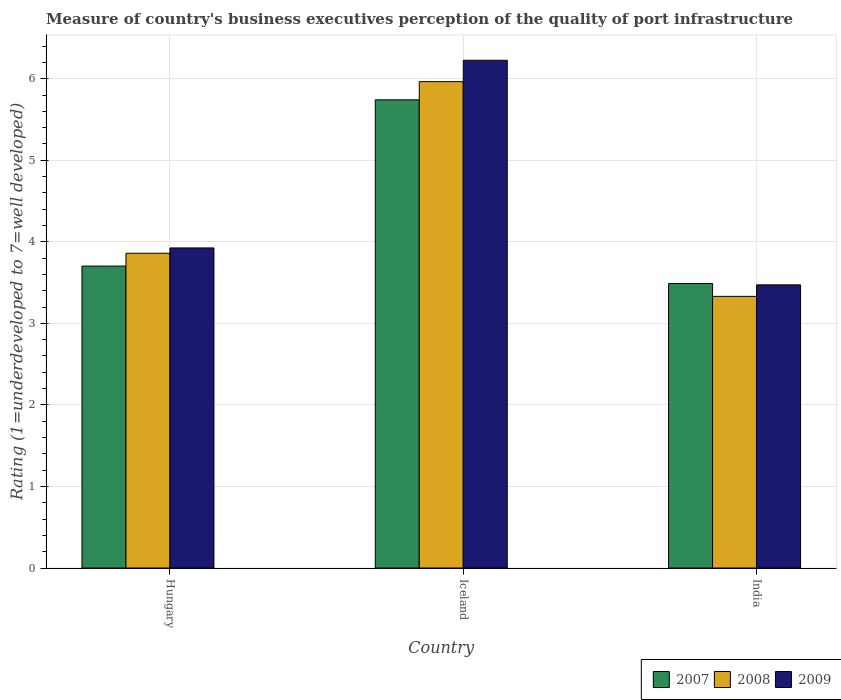Are the number of bars per tick equal to the number of legend labels?
Your answer should be very brief. Yes. How many bars are there on the 2nd tick from the left?
Provide a short and direct response. 3. In how many cases, is the number of bars for a given country not equal to the number of legend labels?
Your answer should be compact. 0. What is the ratings of the quality of port infrastructure in 2009 in Iceland?
Give a very brief answer. 6.23. Across all countries, what is the maximum ratings of the quality of port infrastructure in 2008?
Ensure brevity in your answer.  5.96. Across all countries, what is the minimum ratings of the quality of port infrastructure in 2007?
Ensure brevity in your answer.  3.49. In which country was the ratings of the quality of port infrastructure in 2009 maximum?
Your answer should be compact. Iceland. What is the total ratings of the quality of port infrastructure in 2009 in the graph?
Your answer should be compact. 13.62. What is the difference between the ratings of the quality of port infrastructure in 2008 in Hungary and that in Iceland?
Offer a terse response. -2.1. What is the difference between the ratings of the quality of port infrastructure in 2007 in Iceland and the ratings of the quality of port infrastructure in 2008 in India?
Ensure brevity in your answer.  2.41. What is the average ratings of the quality of port infrastructure in 2008 per country?
Your answer should be very brief. 4.39. What is the difference between the ratings of the quality of port infrastructure of/in 2008 and ratings of the quality of port infrastructure of/in 2007 in India?
Keep it short and to the point. -0.16. In how many countries, is the ratings of the quality of port infrastructure in 2008 greater than 1?
Your answer should be very brief. 3. What is the ratio of the ratings of the quality of port infrastructure in 2008 in Iceland to that in India?
Your answer should be very brief. 1.79. Is the difference between the ratings of the quality of port infrastructure in 2008 in Iceland and India greater than the difference between the ratings of the quality of port infrastructure in 2007 in Iceland and India?
Offer a very short reply. Yes. What is the difference between the highest and the second highest ratings of the quality of port infrastructure in 2008?
Ensure brevity in your answer.  -0.53. What is the difference between the highest and the lowest ratings of the quality of port infrastructure in 2007?
Your answer should be compact. 2.25. Is the sum of the ratings of the quality of port infrastructure in 2007 in Iceland and India greater than the maximum ratings of the quality of port infrastructure in 2009 across all countries?
Offer a very short reply. Yes. What does the 2nd bar from the right in India represents?
Keep it short and to the point. 2008. Is it the case that in every country, the sum of the ratings of the quality of port infrastructure in 2008 and ratings of the quality of port infrastructure in 2007 is greater than the ratings of the quality of port infrastructure in 2009?
Ensure brevity in your answer.  Yes. How many countries are there in the graph?
Give a very brief answer. 3. What is the difference between two consecutive major ticks on the Y-axis?
Ensure brevity in your answer.  1. Are the values on the major ticks of Y-axis written in scientific E-notation?
Provide a succinct answer. No. Does the graph contain grids?
Give a very brief answer. Yes. Where does the legend appear in the graph?
Ensure brevity in your answer.  Bottom right. What is the title of the graph?
Your response must be concise. Measure of country's business executives perception of the quality of port infrastructure. What is the label or title of the Y-axis?
Your answer should be very brief. Rating (1=underdeveloped to 7=well developed). What is the Rating (1=underdeveloped to 7=well developed) in 2007 in Hungary?
Give a very brief answer. 3.7. What is the Rating (1=underdeveloped to 7=well developed) of 2008 in Hungary?
Your answer should be very brief. 3.86. What is the Rating (1=underdeveloped to 7=well developed) of 2009 in Hungary?
Offer a very short reply. 3.93. What is the Rating (1=underdeveloped to 7=well developed) in 2007 in Iceland?
Offer a terse response. 5.74. What is the Rating (1=underdeveloped to 7=well developed) in 2008 in Iceland?
Provide a succinct answer. 5.96. What is the Rating (1=underdeveloped to 7=well developed) in 2009 in Iceland?
Your answer should be very brief. 6.23. What is the Rating (1=underdeveloped to 7=well developed) in 2007 in India?
Your answer should be very brief. 3.49. What is the Rating (1=underdeveloped to 7=well developed) of 2008 in India?
Your response must be concise. 3.33. What is the Rating (1=underdeveloped to 7=well developed) of 2009 in India?
Your response must be concise. 3.47. Across all countries, what is the maximum Rating (1=underdeveloped to 7=well developed) of 2007?
Keep it short and to the point. 5.74. Across all countries, what is the maximum Rating (1=underdeveloped to 7=well developed) of 2008?
Give a very brief answer. 5.96. Across all countries, what is the maximum Rating (1=underdeveloped to 7=well developed) in 2009?
Make the answer very short. 6.23. Across all countries, what is the minimum Rating (1=underdeveloped to 7=well developed) in 2007?
Make the answer very short. 3.49. Across all countries, what is the minimum Rating (1=underdeveloped to 7=well developed) of 2008?
Provide a short and direct response. 3.33. Across all countries, what is the minimum Rating (1=underdeveloped to 7=well developed) in 2009?
Ensure brevity in your answer.  3.47. What is the total Rating (1=underdeveloped to 7=well developed) of 2007 in the graph?
Your answer should be very brief. 12.93. What is the total Rating (1=underdeveloped to 7=well developed) of 2008 in the graph?
Your answer should be compact. 13.16. What is the total Rating (1=underdeveloped to 7=well developed) of 2009 in the graph?
Offer a very short reply. 13.62. What is the difference between the Rating (1=underdeveloped to 7=well developed) in 2007 in Hungary and that in Iceland?
Your answer should be very brief. -2.04. What is the difference between the Rating (1=underdeveloped to 7=well developed) in 2008 in Hungary and that in Iceland?
Give a very brief answer. -2.1. What is the difference between the Rating (1=underdeveloped to 7=well developed) of 2009 in Hungary and that in Iceland?
Your answer should be compact. -2.3. What is the difference between the Rating (1=underdeveloped to 7=well developed) of 2007 in Hungary and that in India?
Offer a very short reply. 0.21. What is the difference between the Rating (1=underdeveloped to 7=well developed) of 2008 in Hungary and that in India?
Give a very brief answer. 0.53. What is the difference between the Rating (1=underdeveloped to 7=well developed) of 2009 in Hungary and that in India?
Keep it short and to the point. 0.45. What is the difference between the Rating (1=underdeveloped to 7=well developed) in 2007 in Iceland and that in India?
Your answer should be compact. 2.25. What is the difference between the Rating (1=underdeveloped to 7=well developed) of 2008 in Iceland and that in India?
Ensure brevity in your answer.  2.63. What is the difference between the Rating (1=underdeveloped to 7=well developed) in 2009 in Iceland and that in India?
Your response must be concise. 2.75. What is the difference between the Rating (1=underdeveloped to 7=well developed) in 2007 in Hungary and the Rating (1=underdeveloped to 7=well developed) in 2008 in Iceland?
Provide a succinct answer. -2.26. What is the difference between the Rating (1=underdeveloped to 7=well developed) in 2007 in Hungary and the Rating (1=underdeveloped to 7=well developed) in 2009 in Iceland?
Your answer should be compact. -2.52. What is the difference between the Rating (1=underdeveloped to 7=well developed) of 2008 in Hungary and the Rating (1=underdeveloped to 7=well developed) of 2009 in Iceland?
Ensure brevity in your answer.  -2.37. What is the difference between the Rating (1=underdeveloped to 7=well developed) of 2007 in Hungary and the Rating (1=underdeveloped to 7=well developed) of 2008 in India?
Provide a short and direct response. 0.37. What is the difference between the Rating (1=underdeveloped to 7=well developed) of 2007 in Hungary and the Rating (1=underdeveloped to 7=well developed) of 2009 in India?
Offer a very short reply. 0.23. What is the difference between the Rating (1=underdeveloped to 7=well developed) in 2008 in Hungary and the Rating (1=underdeveloped to 7=well developed) in 2009 in India?
Make the answer very short. 0.39. What is the difference between the Rating (1=underdeveloped to 7=well developed) in 2007 in Iceland and the Rating (1=underdeveloped to 7=well developed) in 2008 in India?
Ensure brevity in your answer.  2.41. What is the difference between the Rating (1=underdeveloped to 7=well developed) in 2007 in Iceland and the Rating (1=underdeveloped to 7=well developed) in 2009 in India?
Ensure brevity in your answer.  2.27. What is the difference between the Rating (1=underdeveloped to 7=well developed) in 2008 in Iceland and the Rating (1=underdeveloped to 7=well developed) in 2009 in India?
Your answer should be very brief. 2.49. What is the average Rating (1=underdeveloped to 7=well developed) of 2007 per country?
Offer a very short reply. 4.31. What is the average Rating (1=underdeveloped to 7=well developed) in 2008 per country?
Give a very brief answer. 4.39. What is the average Rating (1=underdeveloped to 7=well developed) in 2009 per country?
Offer a terse response. 4.54. What is the difference between the Rating (1=underdeveloped to 7=well developed) in 2007 and Rating (1=underdeveloped to 7=well developed) in 2008 in Hungary?
Ensure brevity in your answer.  -0.16. What is the difference between the Rating (1=underdeveloped to 7=well developed) in 2007 and Rating (1=underdeveloped to 7=well developed) in 2009 in Hungary?
Offer a terse response. -0.22. What is the difference between the Rating (1=underdeveloped to 7=well developed) of 2008 and Rating (1=underdeveloped to 7=well developed) of 2009 in Hungary?
Offer a terse response. -0.06. What is the difference between the Rating (1=underdeveloped to 7=well developed) in 2007 and Rating (1=underdeveloped to 7=well developed) in 2008 in Iceland?
Ensure brevity in your answer.  -0.22. What is the difference between the Rating (1=underdeveloped to 7=well developed) in 2007 and Rating (1=underdeveloped to 7=well developed) in 2009 in Iceland?
Offer a very short reply. -0.49. What is the difference between the Rating (1=underdeveloped to 7=well developed) of 2008 and Rating (1=underdeveloped to 7=well developed) of 2009 in Iceland?
Your answer should be very brief. -0.26. What is the difference between the Rating (1=underdeveloped to 7=well developed) in 2007 and Rating (1=underdeveloped to 7=well developed) in 2008 in India?
Provide a short and direct response. 0.16. What is the difference between the Rating (1=underdeveloped to 7=well developed) of 2007 and Rating (1=underdeveloped to 7=well developed) of 2009 in India?
Give a very brief answer. 0.02. What is the difference between the Rating (1=underdeveloped to 7=well developed) of 2008 and Rating (1=underdeveloped to 7=well developed) of 2009 in India?
Give a very brief answer. -0.14. What is the ratio of the Rating (1=underdeveloped to 7=well developed) in 2007 in Hungary to that in Iceland?
Give a very brief answer. 0.64. What is the ratio of the Rating (1=underdeveloped to 7=well developed) of 2008 in Hungary to that in Iceland?
Keep it short and to the point. 0.65. What is the ratio of the Rating (1=underdeveloped to 7=well developed) of 2009 in Hungary to that in Iceland?
Offer a very short reply. 0.63. What is the ratio of the Rating (1=underdeveloped to 7=well developed) of 2007 in Hungary to that in India?
Offer a terse response. 1.06. What is the ratio of the Rating (1=underdeveloped to 7=well developed) of 2008 in Hungary to that in India?
Offer a very short reply. 1.16. What is the ratio of the Rating (1=underdeveloped to 7=well developed) of 2009 in Hungary to that in India?
Provide a succinct answer. 1.13. What is the ratio of the Rating (1=underdeveloped to 7=well developed) in 2007 in Iceland to that in India?
Make the answer very short. 1.65. What is the ratio of the Rating (1=underdeveloped to 7=well developed) in 2008 in Iceland to that in India?
Provide a succinct answer. 1.79. What is the ratio of the Rating (1=underdeveloped to 7=well developed) of 2009 in Iceland to that in India?
Offer a terse response. 1.79. What is the difference between the highest and the second highest Rating (1=underdeveloped to 7=well developed) in 2007?
Provide a short and direct response. 2.04. What is the difference between the highest and the second highest Rating (1=underdeveloped to 7=well developed) in 2008?
Make the answer very short. 2.1. What is the difference between the highest and the second highest Rating (1=underdeveloped to 7=well developed) of 2009?
Provide a short and direct response. 2.3. What is the difference between the highest and the lowest Rating (1=underdeveloped to 7=well developed) of 2007?
Give a very brief answer. 2.25. What is the difference between the highest and the lowest Rating (1=underdeveloped to 7=well developed) of 2008?
Keep it short and to the point. 2.63. What is the difference between the highest and the lowest Rating (1=underdeveloped to 7=well developed) of 2009?
Offer a very short reply. 2.75. 